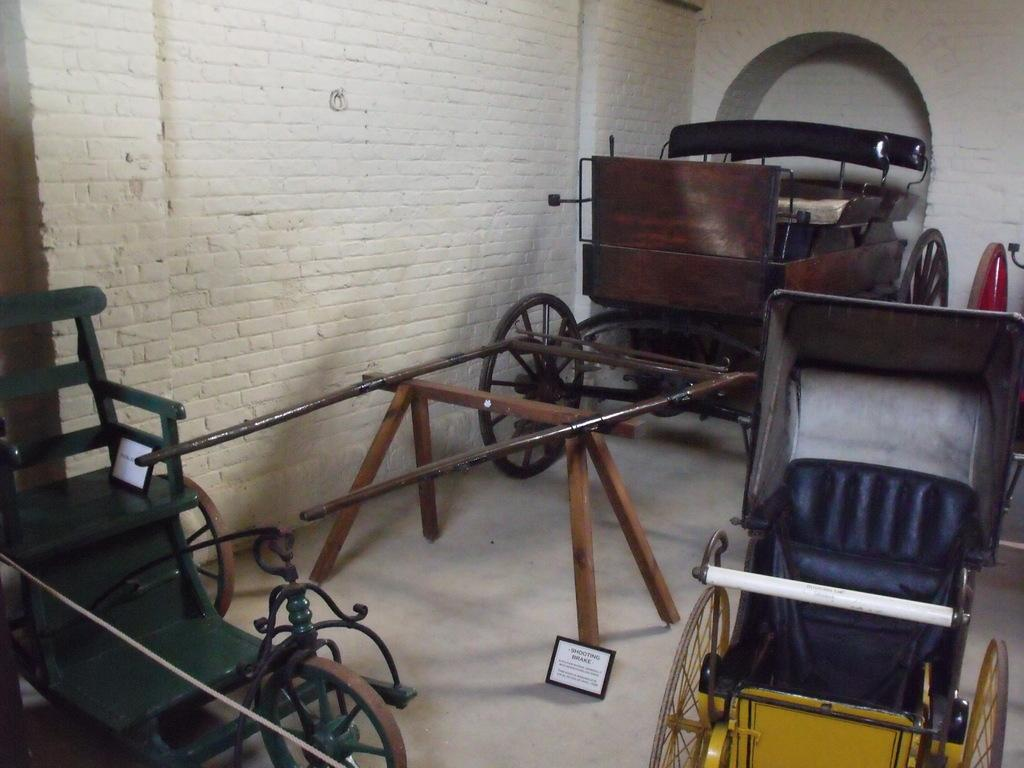What is located in the foreground of the image? There are three cart vehicles and two boards in the foreground of the image. Where are the cart vehicles positioned in the image? The cart vehicles are on the floor in the foreground of the image. What can be seen in the background of the image? There is a wall and an arch in the background of the image. How many boys are wearing masks in the image? There are no boys or masks present in the image. What thought is being expressed by the cart vehicles in the image? Cart vehicles do not have thoughts, as they are inanimate objects. 